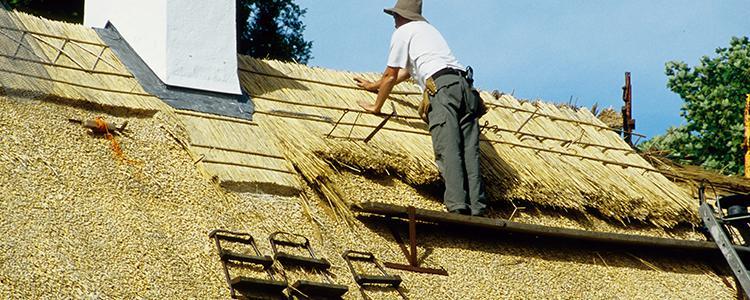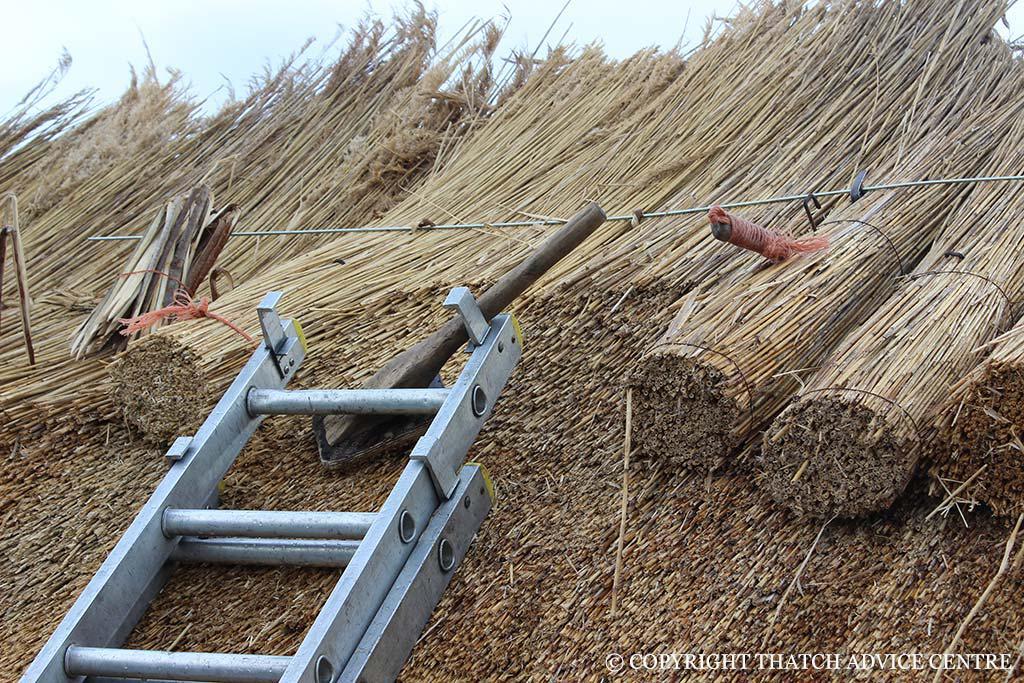The first image is the image on the left, the second image is the image on the right. Considering the images on both sides, is "The left image shows a man installing a thatch roof, and the right image shows a ladder propped on an unfinished roof piled with thatch." valid? Answer yes or no. Yes. The first image is the image on the left, the second image is the image on the right. Considering the images on both sides, is "There are windows in the right image." valid? Answer yes or no. No. 